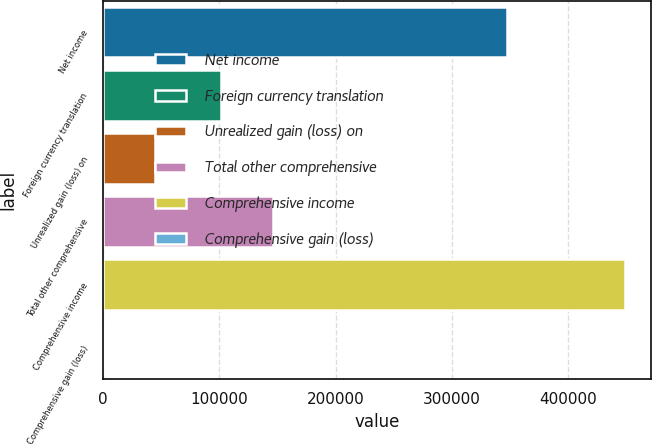Convert chart to OTSL. <chart><loc_0><loc_0><loc_500><loc_500><bar_chart><fcel>Net income<fcel>Foreign currency translation<fcel>Unrealized gain (loss) on<fcel>Total other comprehensive<fcel>Comprehensive income<fcel>Comprehensive gain (loss)<nl><fcel>347588<fcel>100999<fcel>44910.6<fcel>145879<fcel>448796<fcel>31<nl></chart> 